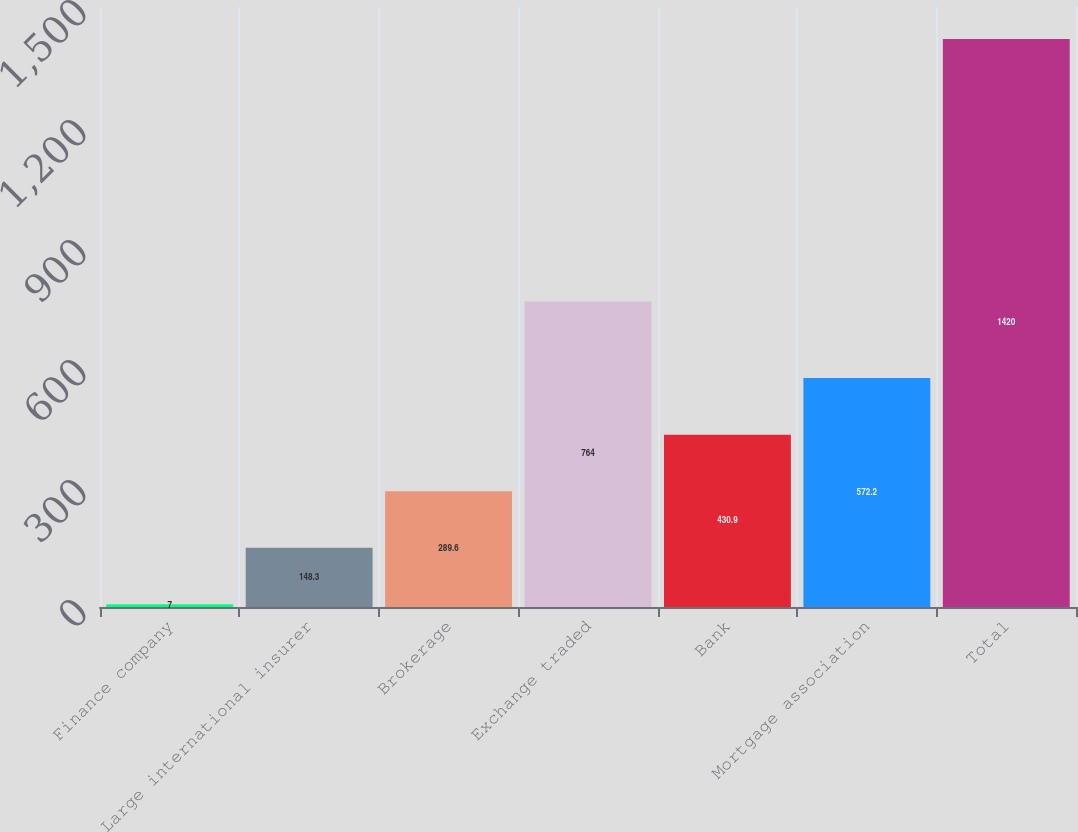Convert chart to OTSL. <chart><loc_0><loc_0><loc_500><loc_500><bar_chart><fcel>Finance company<fcel>Large international insurer<fcel>Brokerage<fcel>Exchange traded<fcel>Bank<fcel>Mortgage association<fcel>Total<nl><fcel>7<fcel>148.3<fcel>289.6<fcel>764<fcel>430.9<fcel>572.2<fcel>1420<nl></chart> 